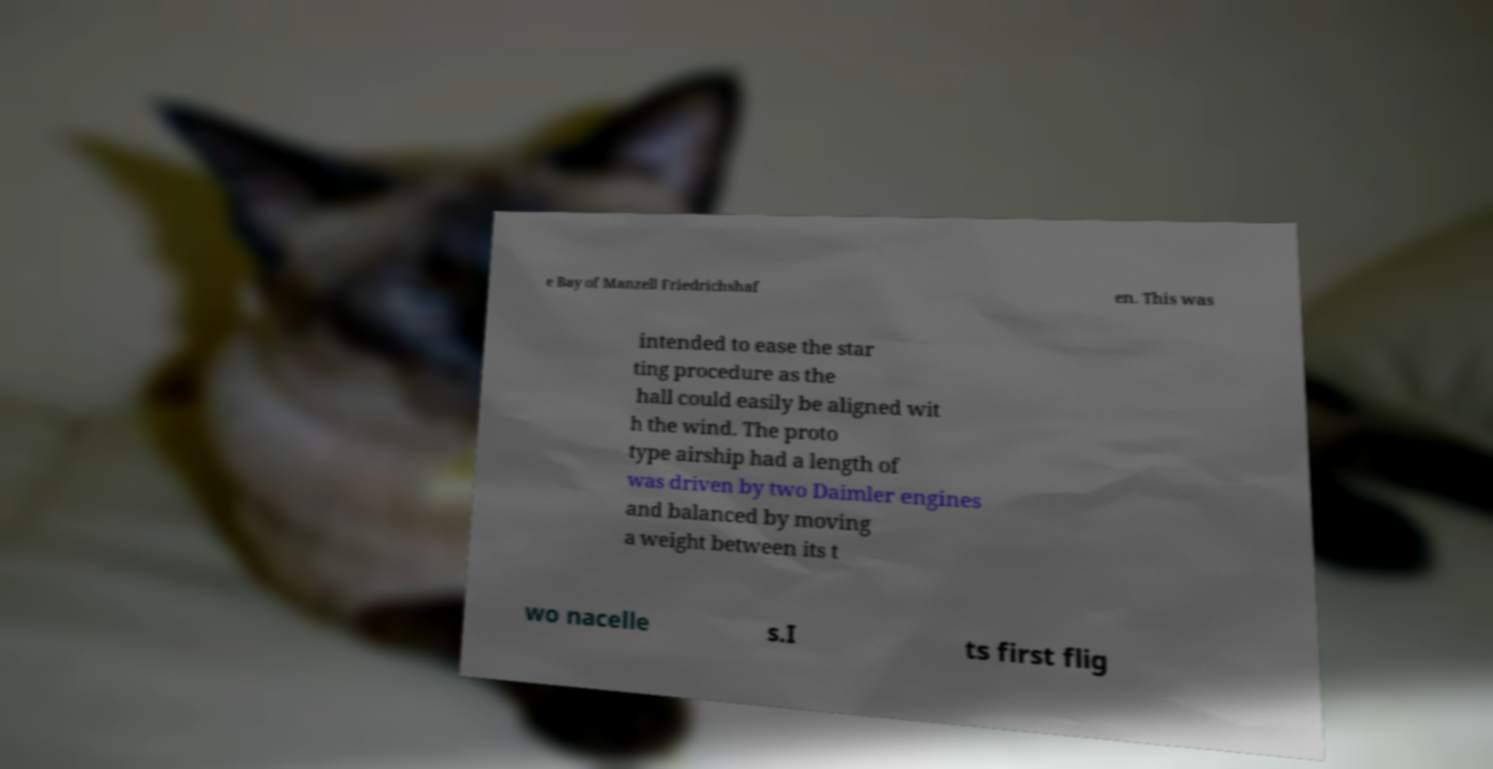What messages or text are displayed in this image? I need them in a readable, typed format. e Bay of Manzell Friedrichshaf en. This was intended to ease the star ting procedure as the hall could easily be aligned wit h the wind. The proto type airship had a length of was driven by two Daimler engines and balanced by moving a weight between its t wo nacelle s.I ts first flig 